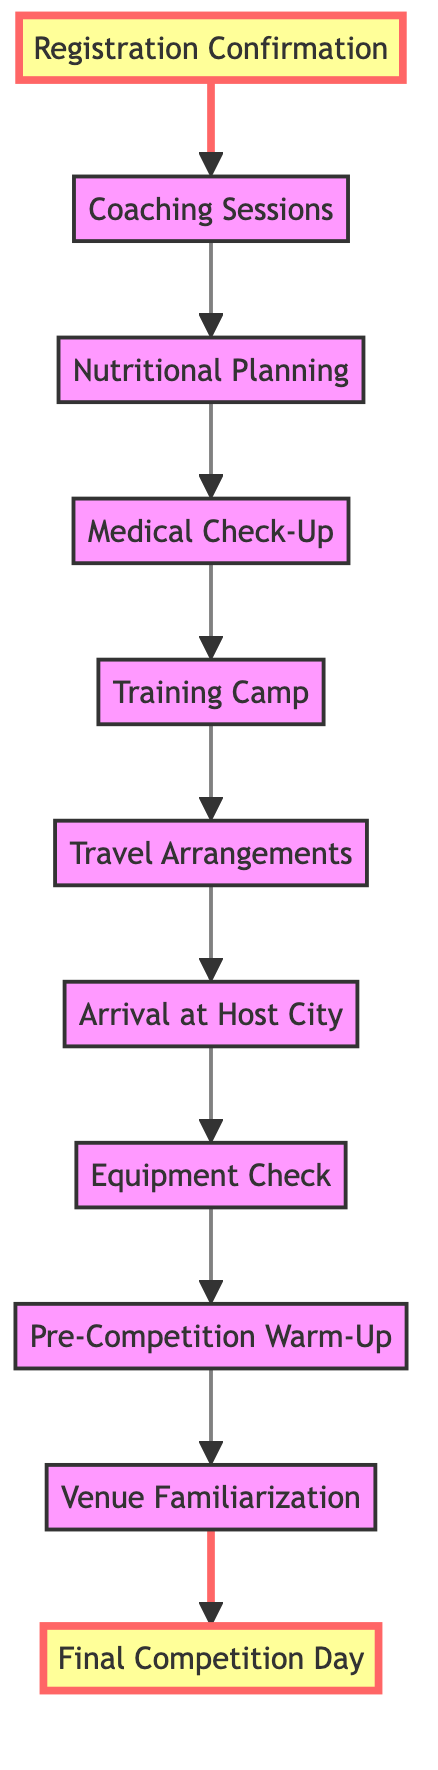What is the first step after Registration Confirmation? From the diagram, the step that follows "Registration Confirmation" is "Coaching Sessions." This is clearly indicated in the flowchart where an arrow points from the node labeled "Registration Confirmation" to the node labeled "Coaching Sessions."
Answer: Coaching Sessions How many steps are there before the Final Competition Day? To determine the number of steps before the "Final Competition Day," we can count the nodes that lead to it: "Venue Familiarization," "Pre-Competition Warm-Up," "Equipment Check," "Arrival at Host City," "Travel Arrangements," "Training Camp," "Medical Check-Up," "Nutritional Planning," and "Coaching Sessions." This totals nine steps.
Answer: 9 What step follows the Medical Check-Up? The diagram clearly shows that after "Medical Check-Up," the next step is "Training Camp." This is indicated by the directional arrow connecting these two nodes in the flowchart.
Answer: Training Camp Which step comes after Arrival at Host City? According to the flowchart, after "Arrival at Host City," the next step is "Equipment Check." The arrow signifies this relationship between the two nodes in the diagram.
Answer: Equipment Check What is the last step before the Final Competition Day? Following the flowchart, the last step before reaching "Final Competition Day" is "Venue Familiarization." This can be seen as the preceding node with an arrow directing towards the final node.
Answer: Venue Familiarization Which element requires ensuring equipment is in good condition? The node that references ensuring equipment is in good condition is "Equipment Check." This is explicitly noted in the description of that particular step in the flowchart.
Answer: Equipment Check How does one prepare nutritionally according to the diagram? From the flowchart, the step that addresses nutritional preparation is "Nutritional Planning." This step follows "Coaching Sessions" and shows the focus on working with a sports nutritionist for diet planning.
Answer: Nutritional Planning What happens immediately before the Pre-Competition Warm-Up? Looking at the diagram, the immediate step before "Pre-Competition Warm-Up" is "Equipment Check." The arrow connects these two nodes in the flowchart, indicating this order.
Answer: Equipment Check 